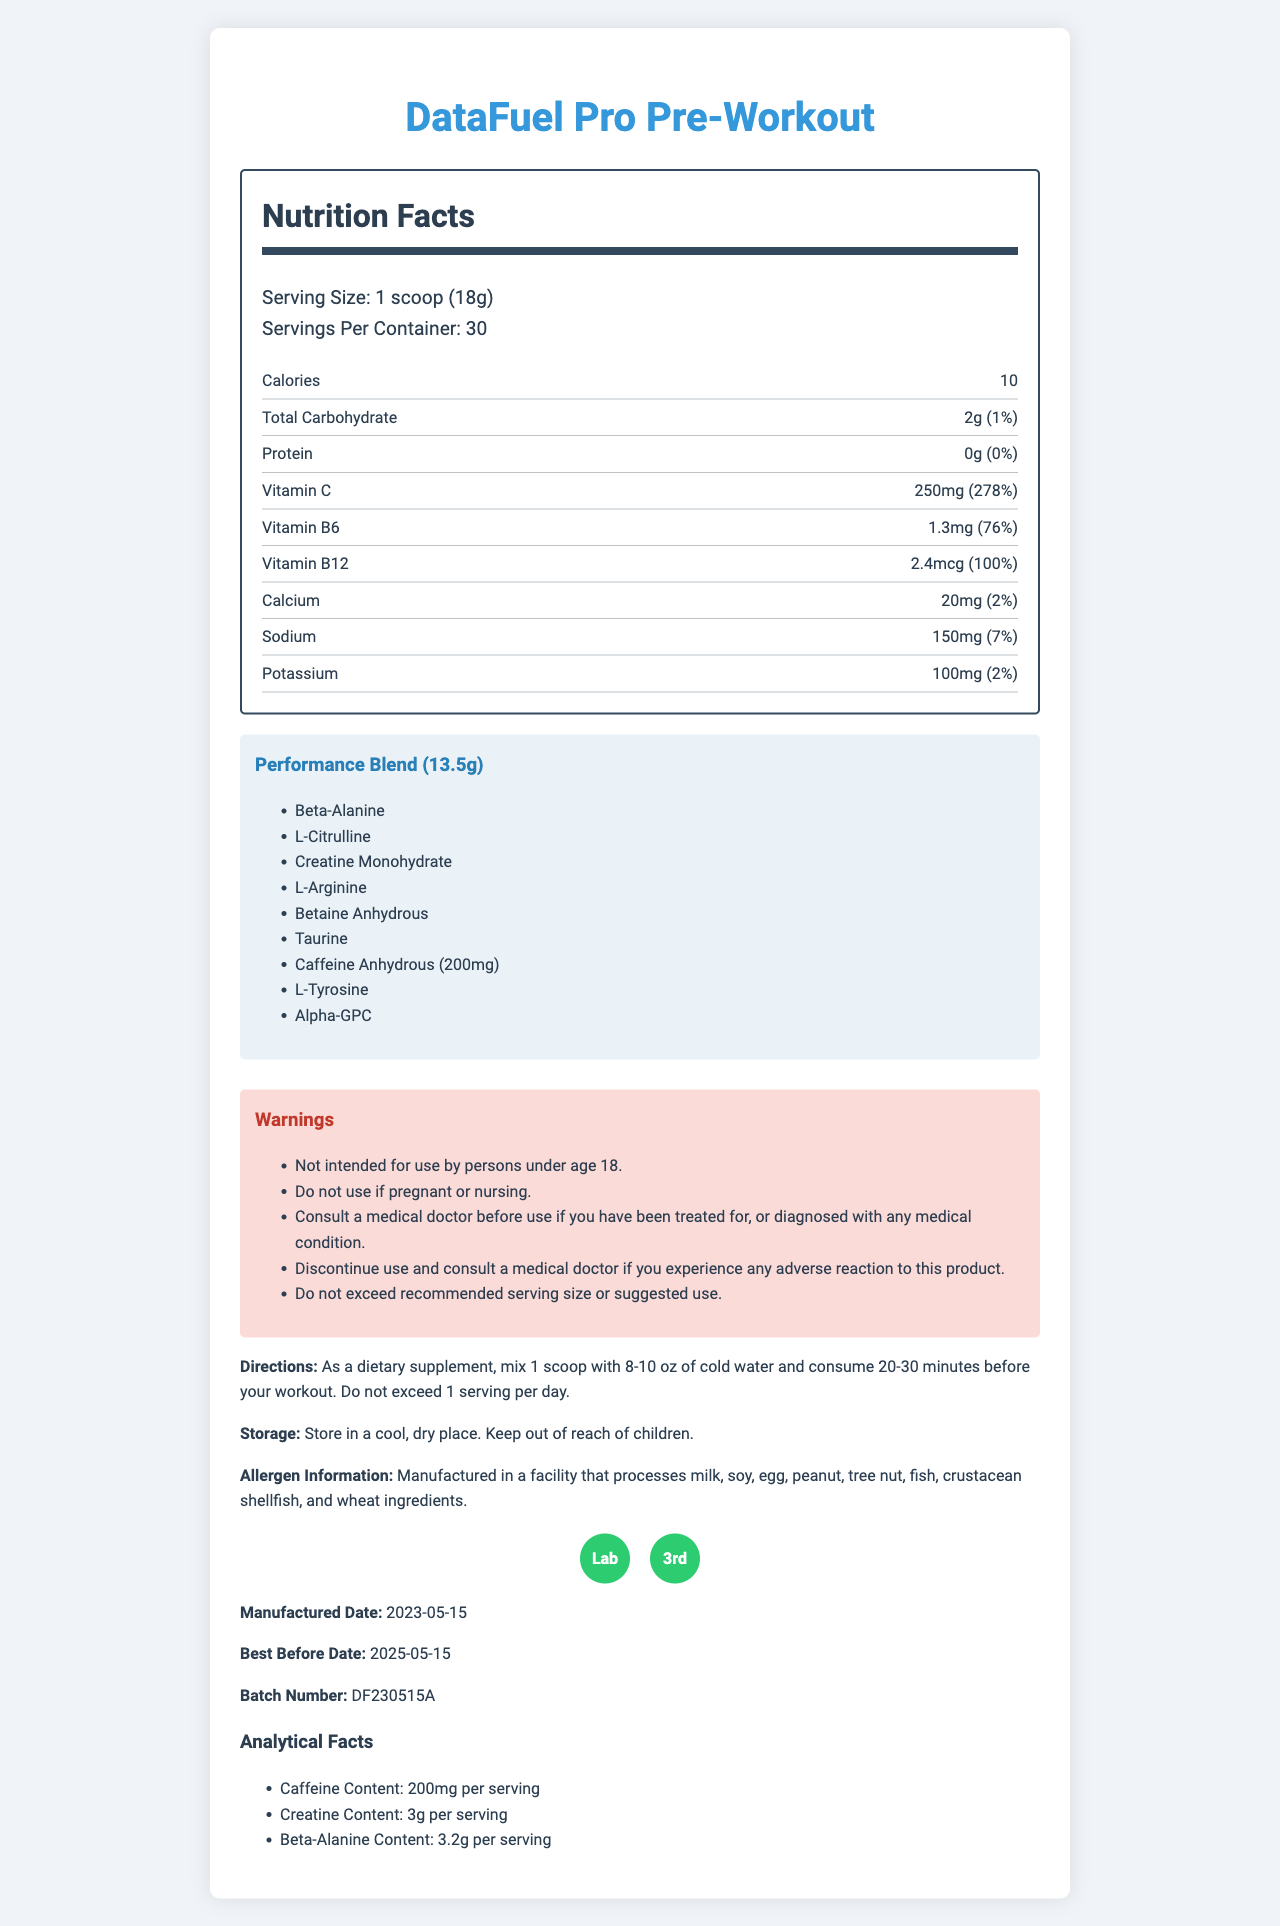what is the serving size for DataFuel Pro Pre-Workout? The serving size is explicitly mentioned as "1 scoop (18g)" in the Nutrition Facts section.
Answer: 1 scoop (18g) how many servings are in one container? The document states that there are 30 servings per container in the serving information section.
Answer: 30 how many calories are in one serving of DataFuel Pro Pre-Workout? The calories content per serving is listed as 10 calories in the Nutrition Facts.
Answer: 10 what is the amount of Vitamin C per serving, and its daily value percentage? The document specifies that there is 250mg of Vitamin C per serving, which is 278% of the daily value.
Answer: 250mg, 278% list three key performance ingredients in the performance blend. The performance blend lists Beta-Alanine, L-Citrulline, and Creatine Monohydrate as part of its ingredients.
Answer: Beta-Alanine, L-Citrulline, Creatine Monohydrate how much caffeine does one serving of the supplement contain? A. 100mg B. 150mg C. 200mg D. 250mg The document specifies that each serving contains 200mg of Caffeine Anhydrous.
Answer: C. 200mg what is the recommended way to consume the supplement? The directions section advises mixing 1 scoop with 8-10 oz of cold water and consuming it 20-30 minutes before a workout.
Answer: Mix 1 scoop with 8-10 oz of cold water and consume 20-30 minutes before your workout. which vitamin has the highest daily value percentage in this supplement? A. Vitamin C B. Vitamin B6 C. Vitamin B12 D. Calcium Vitamin C has the highest daily value percentage at 278%, compared to Vitamin B6 (76%), Vitamin B12 (100%), and Calcium (2%).
Answer: A. Vitamin C is the product suitable for someone who is pregnant? One of the warnings explicitly states that the product should not be used if pregnant or nursing.
Answer: No why is it important to consult a medical doctor before using this supplement? The warnings section advises consulting a medical doctor before use if you have any medical conditions to ensure safety.
Answer: To ensure safety if you have been treated for or diagnosed with any medical condition. describe the main idea of the DataFuel Pro Pre-Workout supplement document. The document covers all critical aspects of the supplement, including nutritional content, usage instructions, safety warnings, and additional analytical facts to help users understand how to use the product effectively and safely.
Answer: The document provides detailed nutrition facts, serving size, performance ingredients, directions for use, warnings, allergen information, storage instructions, certifications, and analytical facts about the DataFuel Pro Pre-Workout supplement. what is the exact amount of beta-alanine in the performance blend? The document states the total amount of the performance blend (13.5g) and lists beta-alanine as an ingredient but does not provide the specific quantity of beta-alanine separately.
Answer: Cannot be determined 